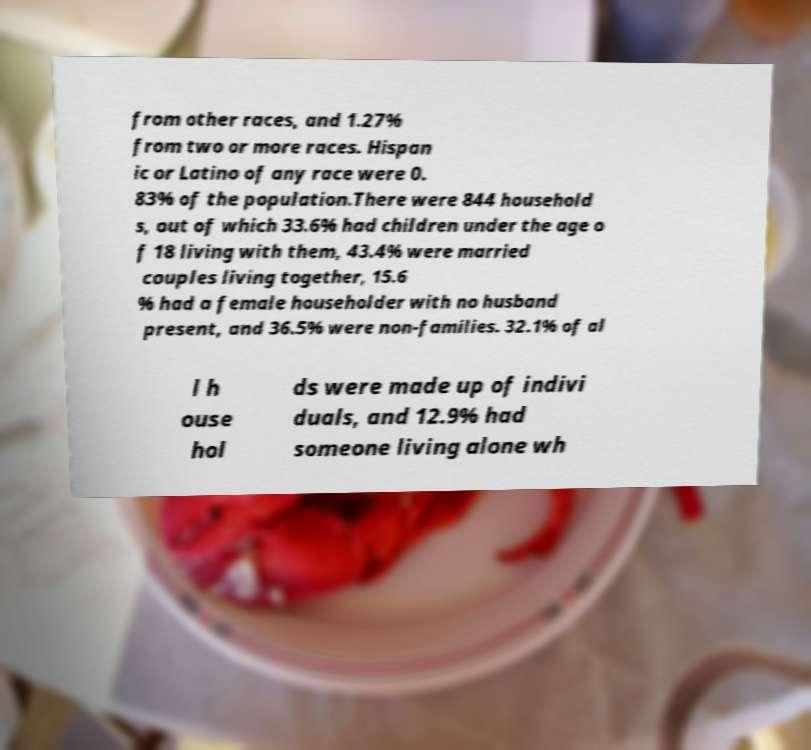Please read and relay the text visible in this image. What does it say? from other races, and 1.27% from two or more races. Hispan ic or Latino of any race were 0. 83% of the population.There were 844 household s, out of which 33.6% had children under the age o f 18 living with them, 43.4% were married couples living together, 15.6 % had a female householder with no husband present, and 36.5% were non-families. 32.1% of al l h ouse hol ds were made up of indivi duals, and 12.9% had someone living alone wh 